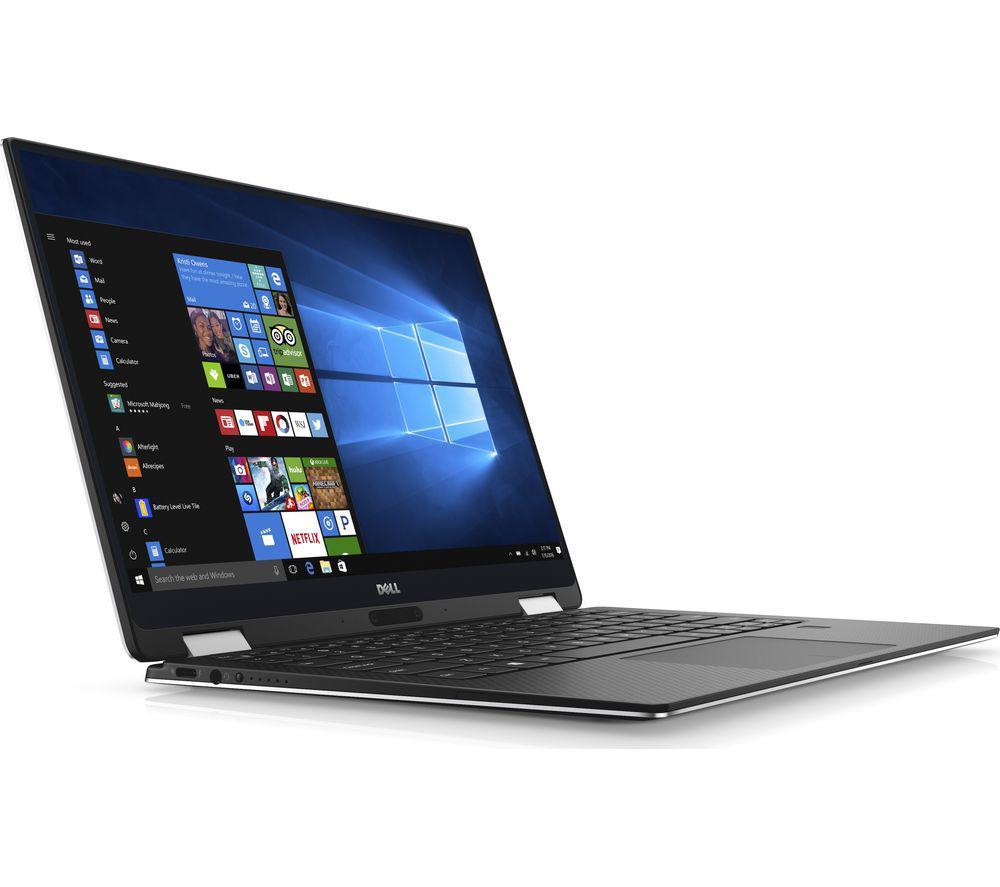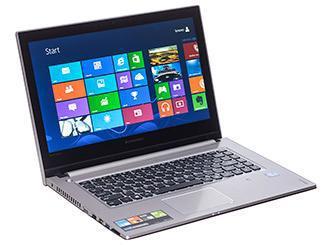The first image is the image on the left, the second image is the image on the right. Analyze the images presented: Is the assertion "There is one computer in each image." valid? Answer yes or no. Yes. The first image is the image on the left, the second image is the image on the right. Examine the images to the left and right. Is the description "The left and right image contains the same number of two in one laptops." accurate? Answer yes or no. Yes. 